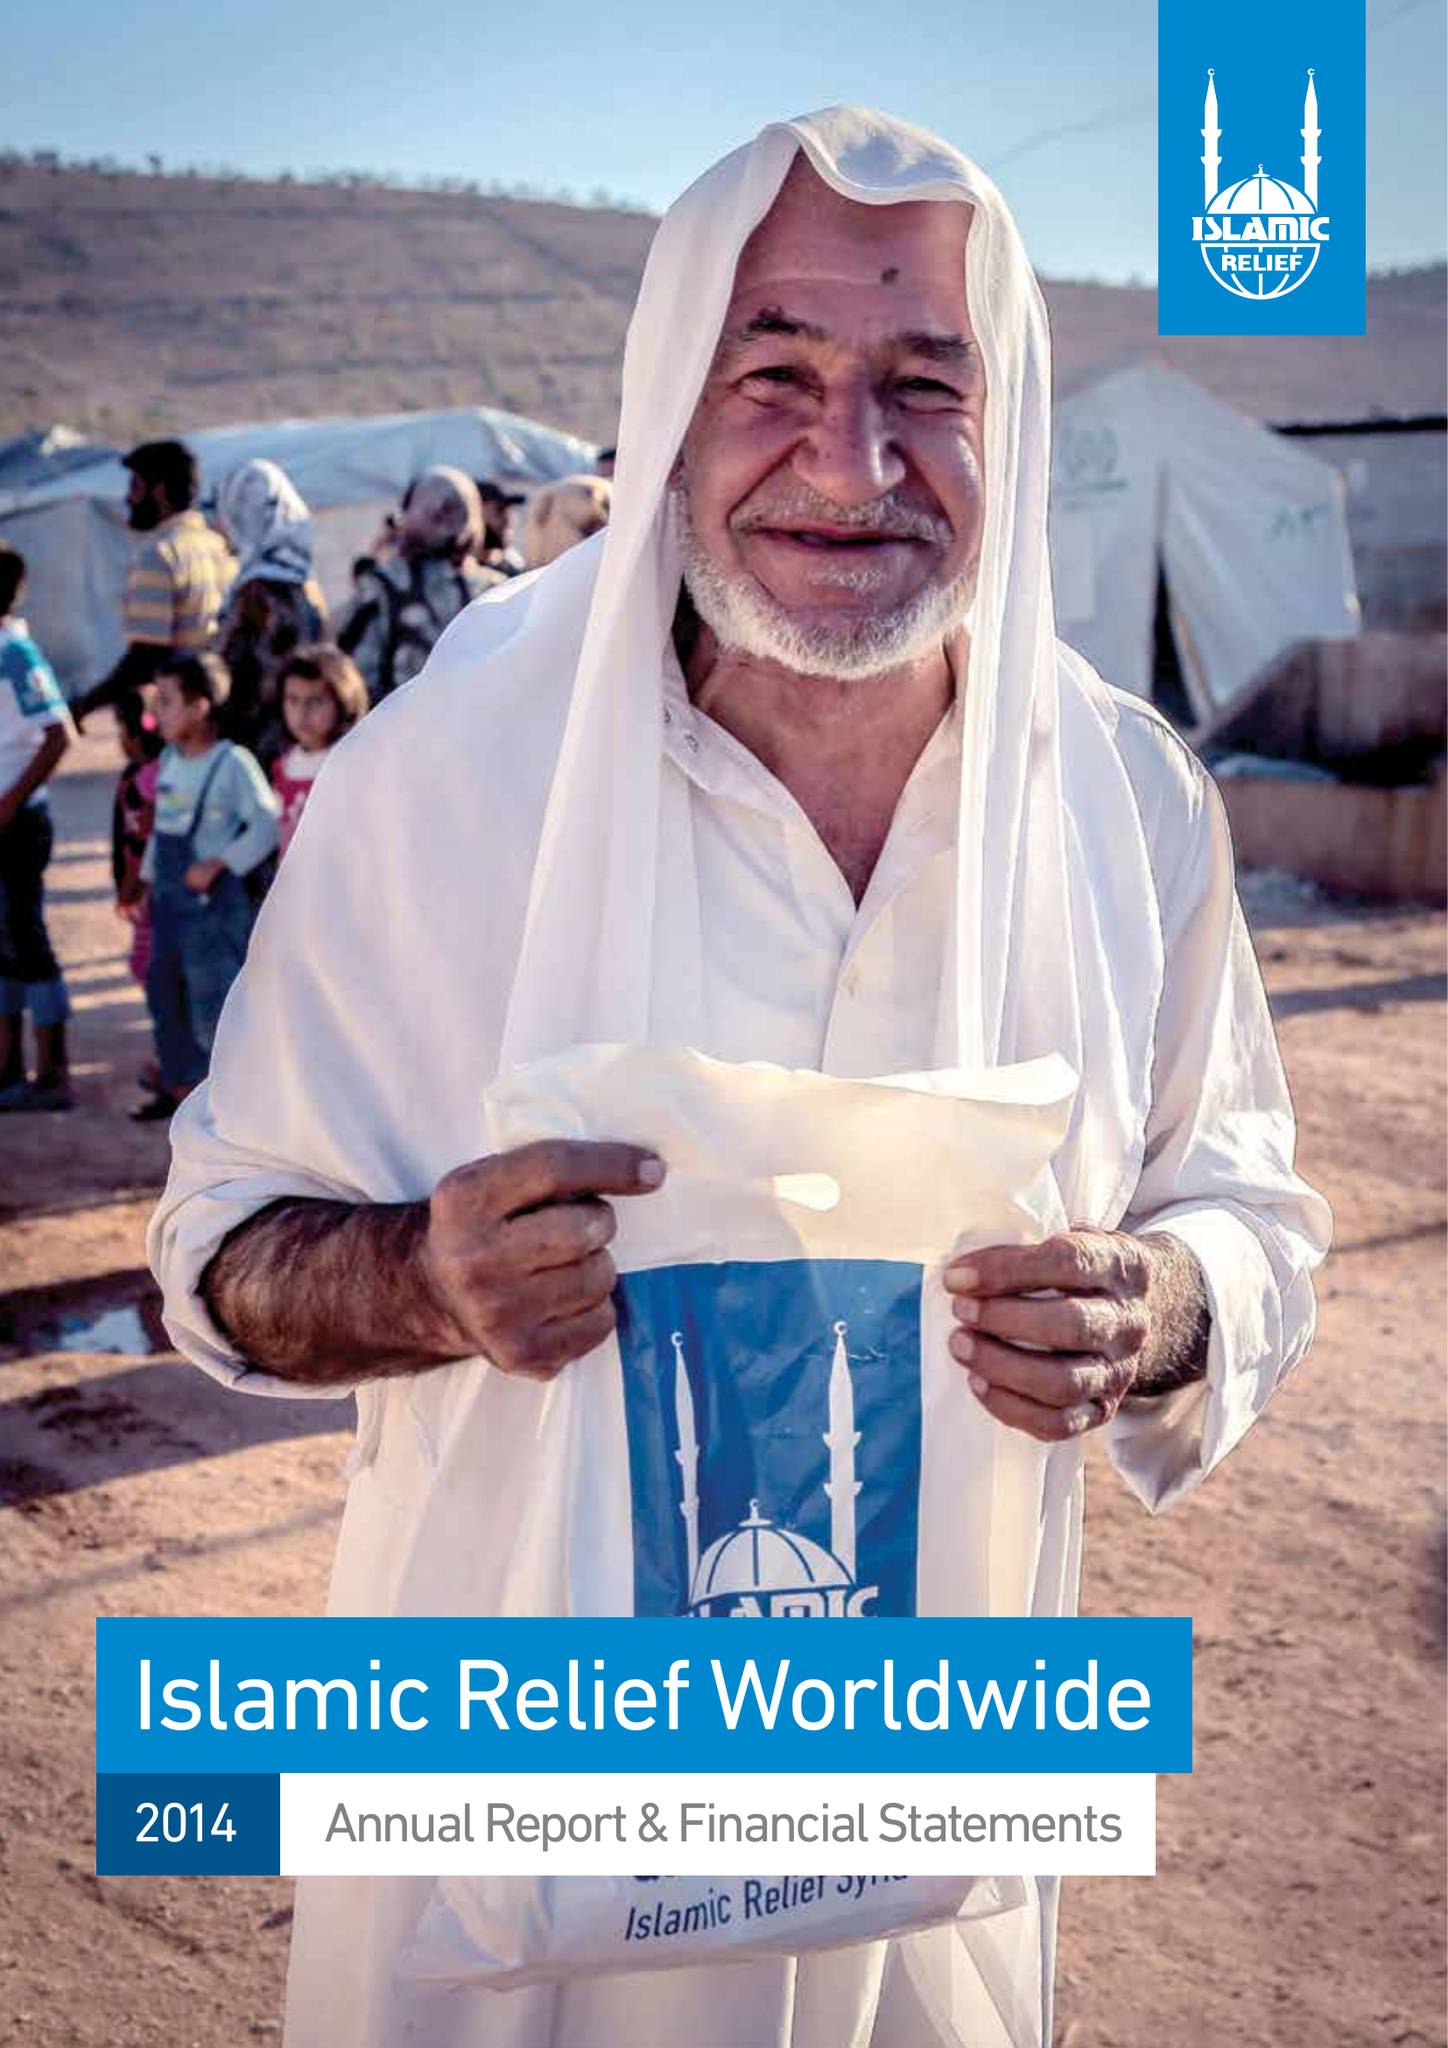What is the value for the charity_name?
Answer the question using a single word or phrase. Islamic Relief Worldwide 